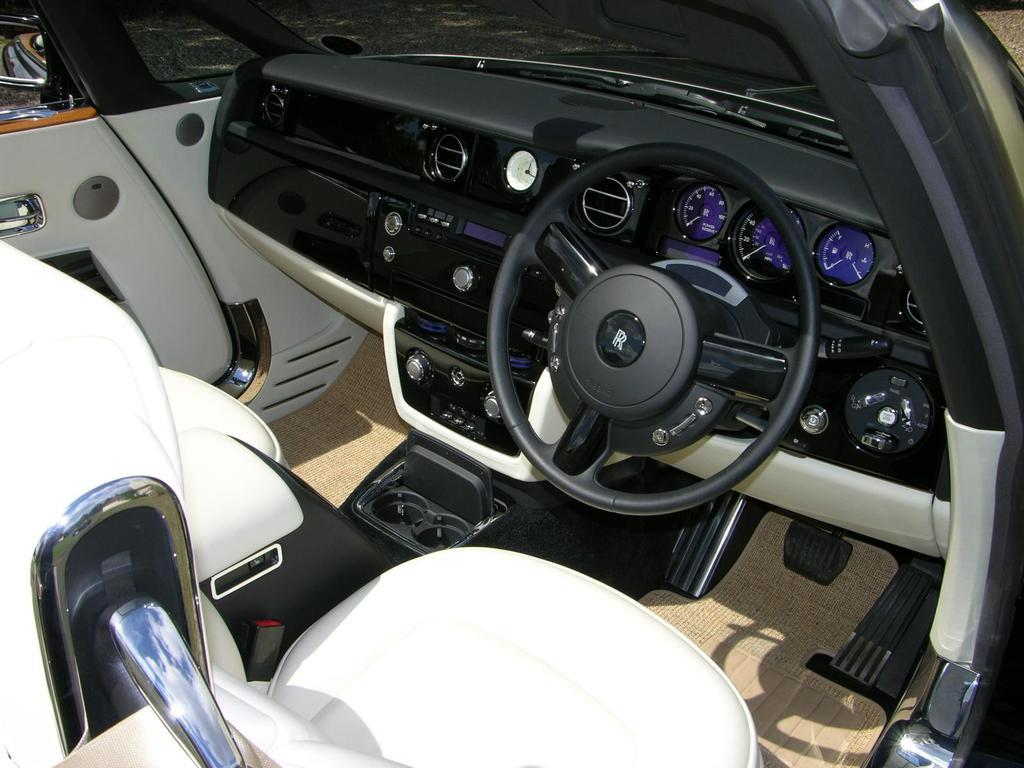What is the main subject of the image? There is a vehicle in the image. Can you describe the perspective of the image? The image provides an inside view of the vehicle. What type of creature can be seen partying inside the vehicle in the image? There is no creature or party present in the image; it shows an inside view of the vehicle. 